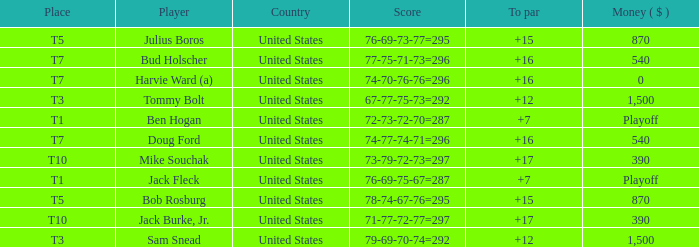Which money has player Jack Fleck with t1 place? Playoff. 